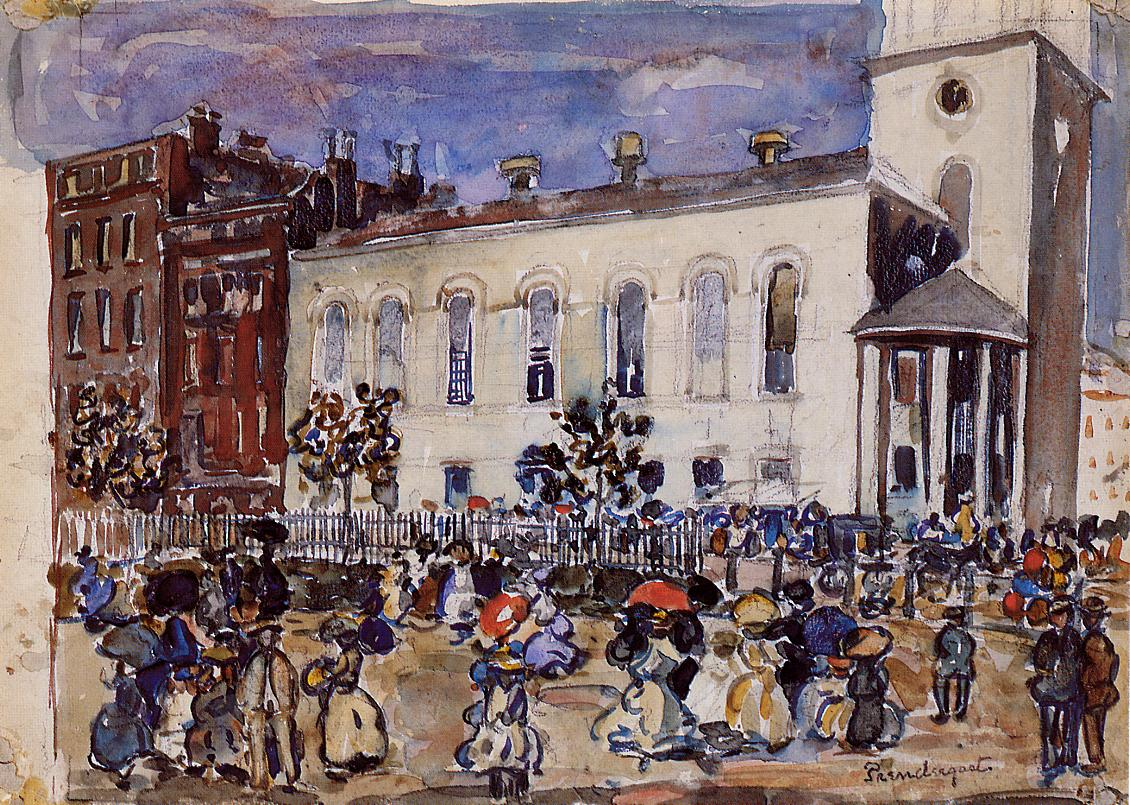Can you describe the architecture of the buildings in the image? The architecture in the image showcases a blend of historic and early 20th-century designs. The white building with a tall tower stands out prominently; it features large arched windows and a series of columns supporting a pediment at the tower's entrance, indicative of neoclassical influences. Adjacent to it, a red brick building displays more utilitarian design, with rectangular windows and simple lines, reflecting the industrial aesthetics of the era. The buildings are depicted using loose brushstrokes that suggest the architectural details while preserving the impressionist style's fluidity. 